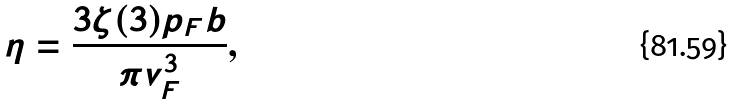Convert formula to latex. <formula><loc_0><loc_0><loc_500><loc_500>\eta = \frac { 3 \zeta ( 3 ) p _ { F } b } { \pi v _ { F } ^ { 3 } } ,</formula> 